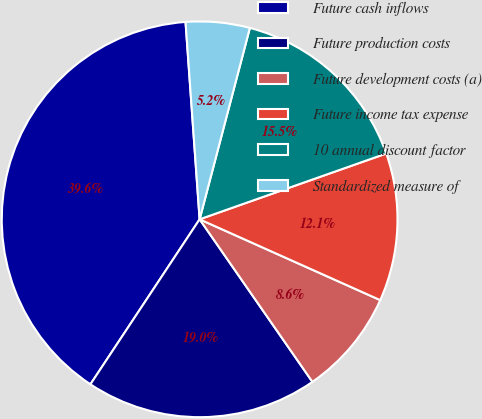Convert chart. <chart><loc_0><loc_0><loc_500><loc_500><pie_chart><fcel>Future cash inflows<fcel>Future production costs<fcel>Future development costs (a)<fcel>Future income tax expense<fcel>10 annual discount factor<fcel>Standardized measure of<nl><fcel>39.56%<fcel>18.96%<fcel>8.65%<fcel>12.09%<fcel>15.52%<fcel>5.22%<nl></chart> 